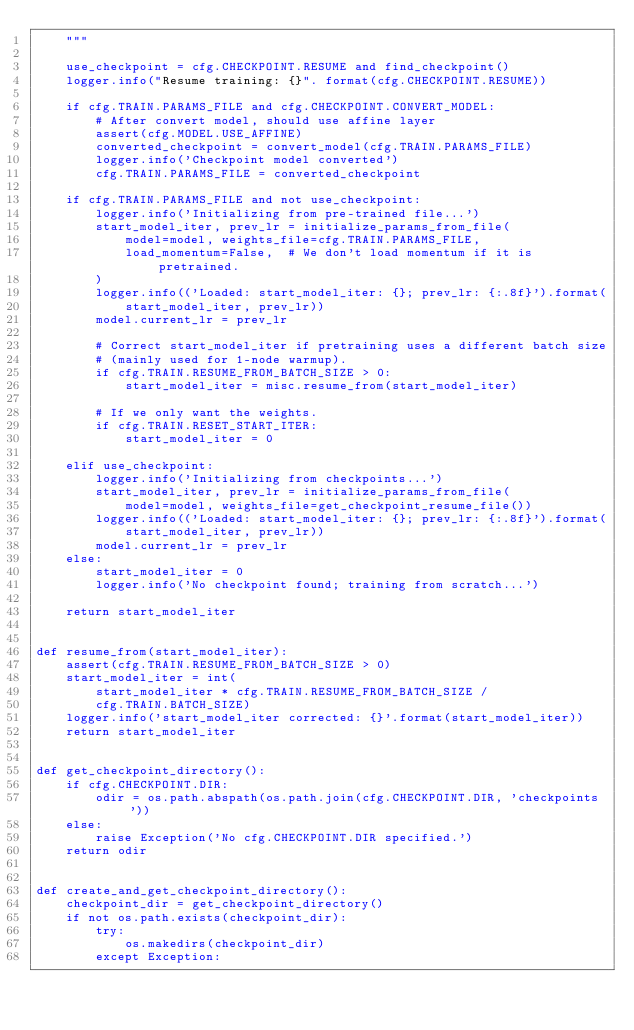Convert code to text. <code><loc_0><loc_0><loc_500><loc_500><_Python_>    """

    use_checkpoint = cfg.CHECKPOINT.RESUME and find_checkpoint()
    logger.info("Resume training: {}". format(cfg.CHECKPOINT.RESUME))

    if cfg.TRAIN.PARAMS_FILE and cfg.CHECKPOINT.CONVERT_MODEL:
        # After convert model, should use affine layer
        assert(cfg.MODEL.USE_AFFINE)
        converted_checkpoint = convert_model(cfg.TRAIN.PARAMS_FILE)
        logger.info('Checkpoint model converted')
        cfg.TRAIN.PARAMS_FILE = converted_checkpoint

    if cfg.TRAIN.PARAMS_FILE and not use_checkpoint:
        logger.info('Initializing from pre-trained file...')
        start_model_iter, prev_lr = initialize_params_from_file(
            model=model, weights_file=cfg.TRAIN.PARAMS_FILE,
            load_momentum=False,  # We don't load momentum if it is pretrained.
        )
        logger.info(('Loaded: start_model_iter: {}; prev_lr: {:.8f}').format(
            start_model_iter, prev_lr))
        model.current_lr = prev_lr

        # Correct start_model_iter if pretraining uses a different batch size
        # (mainly used for 1-node warmup).
        if cfg.TRAIN.RESUME_FROM_BATCH_SIZE > 0:
            start_model_iter = misc.resume_from(start_model_iter)

        # If we only want the weights.
        if cfg.TRAIN.RESET_START_ITER:
            start_model_iter = 0

    elif use_checkpoint:
        logger.info('Initializing from checkpoints...')
        start_model_iter, prev_lr = initialize_params_from_file(
            model=model, weights_file=get_checkpoint_resume_file())
        logger.info(('Loaded: start_model_iter: {}; prev_lr: {:.8f}').format(
            start_model_iter, prev_lr))
        model.current_lr = prev_lr
    else:
        start_model_iter = 0
        logger.info('No checkpoint found; training from scratch...')

    return start_model_iter


def resume_from(start_model_iter):
    assert(cfg.TRAIN.RESUME_FROM_BATCH_SIZE > 0)
    start_model_iter = int(
        start_model_iter * cfg.TRAIN.RESUME_FROM_BATCH_SIZE /
        cfg.TRAIN.BATCH_SIZE)
    logger.info('start_model_iter corrected: {}'.format(start_model_iter))
    return start_model_iter


def get_checkpoint_directory():
    if cfg.CHECKPOINT.DIR:
        odir = os.path.abspath(os.path.join(cfg.CHECKPOINT.DIR, 'checkpoints'))
    else:
        raise Exception('No cfg.CHECKPOINT.DIR specified.')
    return odir


def create_and_get_checkpoint_directory():
    checkpoint_dir = get_checkpoint_directory()
    if not os.path.exists(checkpoint_dir):
        try:
            os.makedirs(checkpoint_dir)
        except Exception:</code> 